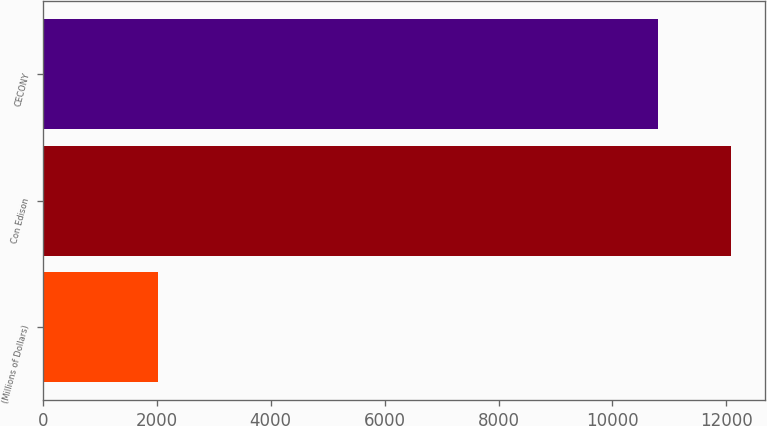<chart> <loc_0><loc_0><loc_500><loc_500><bar_chart><fcel>(Millions of Dollars)<fcel>Con Edison<fcel>CECONY<nl><fcel>2013<fcel>12082<fcel>10797<nl></chart> 